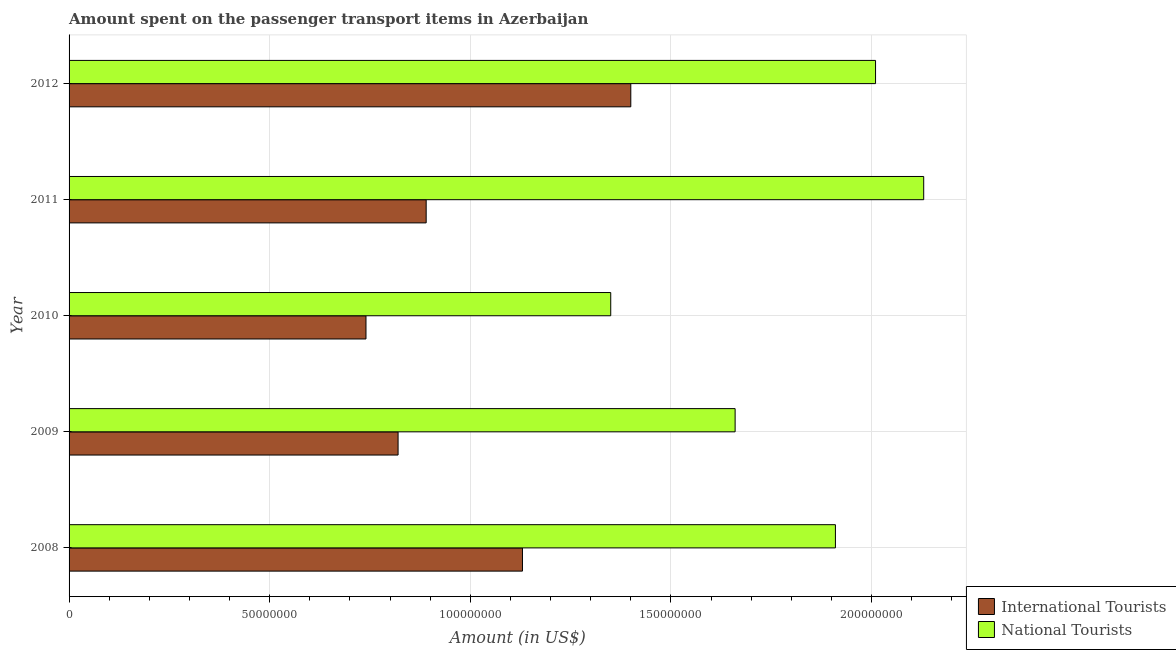How many different coloured bars are there?
Give a very brief answer. 2. How many bars are there on the 3rd tick from the top?
Offer a very short reply. 2. What is the label of the 5th group of bars from the top?
Your response must be concise. 2008. In how many cases, is the number of bars for a given year not equal to the number of legend labels?
Keep it short and to the point. 0. What is the amount spent on transport items of national tourists in 2012?
Your response must be concise. 2.01e+08. Across all years, what is the maximum amount spent on transport items of national tourists?
Your answer should be very brief. 2.13e+08. Across all years, what is the minimum amount spent on transport items of international tourists?
Offer a very short reply. 7.40e+07. In which year was the amount spent on transport items of national tourists maximum?
Your response must be concise. 2011. In which year was the amount spent on transport items of international tourists minimum?
Provide a short and direct response. 2010. What is the total amount spent on transport items of national tourists in the graph?
Your response must be concise. 9.06e+08. What is the difference between the amount spent on transport items of international tourists in 2009 and that in 2011?
Offer a terse response. -7.00e+06. What is the difference between the amount spent on transport items of international tourists in 2012 and the amount spent on transport items of national tourists in 2009?
Offer a very short reply. -2.60e+07. What is the average amount spent on transport items of international tourists per year?
Provide a succinct answer. 9.96e+07. In the year 2012, what is the difference between the amount spent on transport items of national tourists and amount spent on transport items of international tourists?
Ensure brevity in your answer.  6.10e+07. In how many years, is the amount spent on transport items of national tourists greater than 70000000 US$?
Ensure brevity in your answer.  5. What is the ratio of the amount spent on transport items of national tourists in 2009 to that in 2012?
Ensure brevity in your answer.  0.83. Is the difference between the amount spent on transport items of international tourists in 2008 and 2012 greater than the difference between the amount spent on transport items of national tourists in 2008 and 2012?
Keep it short and to the point. No. What is the difference between the highest and the second highest amount spent on transport items of national tourists?
Your response must be concise. 1.20e+07. What is the difference between the highest and the lowest amount spent on transport items of international tourists?
Your answer should be compact. 6.60e+07. In how many years, is the amount spent on transport items of international tourists greater than the average amount spent on transport items of international tourists taken over all years?
Provide a succinct answer. 2. What does the 2nd bar from the top in 2012 represents?
Your answer should be very brief. International Tourists. What does the 1st bar from the bottom in 2012 represents?
Your response must be concise. International Tourists. How many bars are there?
Provide a succinct answer. 10. How many years are there in the graph?
Provide a succinct answer. 5. Are the values on the major ticks of X-axis written in scientific E-notation?
Ensure brevity in your answer.  No. Does the graph contain any zero values?
Provide a succinct answer. No. Does the graph contain grids?
Provide a succinct answer. Yes. How many legend labels are there?
Ensure brevity in your answer.  2. What is the title of the graph?
Offer a terse response. Amount spent on the passenger transport items in Azerbaijan. What is the label or title of the X-axis?
Offer a terse response. Amount (in US$). What is the Amount (in US$) in International Tourists in 2008?
Provide a succinct answer. 1.13e+08. What is the Amount (in US$) of National Tourists in 2008?
Ensure brevity in your answer.  1.91e+08. What is the Amount (in US$) in International Tourists in 2009?
Provide a short and direct response. 8.20e+07. What is the Amount (in US$) of National Tourists in 2009?
Your response must be concise. 1.66e+08. What is the Amount (in US$) in International Tourists in 2010?
Offer a very short reply. 7.40e+07. What is the Amount (in US$) in National Tourists in 2010?
Make the answer very short. 1.35e+08. What is the Amount (in US$) of International Tourists in 2011?
Provide a short and direct response. 8.90e+07. What is the Amount (in US$) of National Tourists in 2011?
Your response must be concise. 2.13e+08. What is the Amount (in US$) of International Tourists in 2012?
Your answer should be compact. 1.40e+08. What is the Amount (in US$) of National Tourists in 2012?
Offer a very short reply. 2.01e+08. Across all years, what is the maximum Amount (in US$) of International Tourists?
Ensure brevity in your answer.  1.40e+08. Across all years, what is the maximum Amount (in US$) of National Tourists?
Your response must be concise. 2.13e+08. Across all years, what is the minimum Amount (in US$) in International Tourists?
Provide a succinct answer. 7.40e+07. Across all years, what is the minimum Amount (in US$) in National Tourists?
Your answer should be very brief. 1.35e+08. What is the total Amount (in US$) of International Tourists in the graph?
Your answer should be compact. 4.98e+08. What is the total Amount (in US$) in National Tourists in the graph?
Give a very brief answer. 9.06e+08. What is the difference between the Amount (in US$) of International Tourists in 2008 and that in 2009?
Offer a very short reply. 3.10e+07. What is the difference between the Amount (in US$) of National Tourists in 2008 and that in 2009?
Offer a terse response. 2.50e+07. What is the difference between the Amount (in US$) of International Tourists in 2008 and that in 2010?
Keep it short and to the point. 3.90e+07. What is the difference between the Amount (in US$) of National Tourists in 2008 and that in 2010?
Provide a short and direct response. 5.60e+07. What is the difference between the Amount (in US$) of International Tourists in 2008 and that in 2011?
Your answer should be very brief. 2.40e+07. What is the difference between the Amount (in US$) of National Tourists in 2008 and that in 2011?
Your response must be concise. -2.20e+07. What is the difference between the Amount (in US$) in International Tourists in 2008 and that in 2012?
Make the answer very short. -2.70e+07. What is the difference between the Amount (in US$) in National Tourists in 2008 and that in 2012?
Ensure brevity in your answer.  -1.00e+07. What is the difference between the Amount (in US$) of National Tourists in 2009 and that in 2010?
Offer a very short reply. 3.10e+07. What is the difference between the Amount (in US$) of International Tourists in 2009 and that in 2011?
Offer a terse response. -7.00e+06. What is the difference between the Amount (in US$) of National Tourists in 2009 and that in 2011?
Provide a short and direct response. -4.70e+07. What is the difference between the Amount (in US$) of International Tourists in 2009 and that in 2012?
Keep it short and to the point. -5.80e+07. What is the difference between the Amount (in US$) of National Tourists in 2009 and that in 2012?
Make the answer very short. -3.50e+07. What is the difference between the Amount (in US$) of International Tourists in 2010 and that in 2011?
Make the answer very short. -1.50e+07. What is the difference between the Amount (in US$) of National Tourists in 2010 and that in 2011?
Provide a succinct answer. -7.80e+07. What is the difference between the Amount (in US$) in International Tourists in 2010 and that in 2012?
Your response must be concise. -6.60e+07. What is the difference between the Amount (in US$) in National Tourists in 2010 and that in 2012?
Keep it short and to the point. -6.60e+07. What is the difference between the Amount (in US$) in International Tourists in 2011 and that in 2012?
Your answer should be very brief. -5.10e+07. What is the difference between the Amount (in US$) in International Tourists in 2008 and the Amount (in US$) in National Tourists in 2009?
Give a very brief answer. -5.30e+07. What is the difference between the Amount (in US$) of International Tourists in 2008 and the Amount (in US$) of National Tourists in 2010?
Your response must be concise. -2.20e+07. What is the difference between the Amount (in US$) of International Tourists in 2008 and the Amount (in US$) of National Tourists in 2011?
Keep it short and to the point. -1.00e+08. What is the difference between the Amount (in US$) in International Tourists in 2008 and the Amount (in US$) in National Tourists in 2012?
Provide a succinct answer. -8.80e+07. What is the difference between the Amount (in US$) in International Tourists in 2009 and the Amount (in US$) in National Tourists in 2010?
Your answer should be very brief. -5.30e+07. What is the difference between the Amount (in US$) in International Tourists in 2009 and the Amount (in US$) in National Tourists in 2011?
Ensure brevity in your answer.  -1.31e+08. What is the difference between the Amount (in US$) in International Tourists in 2009 and the Amount (in US$) in National Tourists in 2012?
Your response must be concise. -1.19e+08. What is the difference between the Amount (in US$) of International Tourists in 2010 and the Amount (in US$) of National Tourists in 2011?
Your answer should be compact. -1.39e+08. What is the difference between the Amount (in US$) in International Tourists in 2010 and the Amount (in US$) in National Tourists in 2012?
Offer a terse response. -1.27e+08. What is the difference between the Amount (in US$) in International Tourists in 2011 and the Amount (in US$) in National Tourists in 2012?
Keep it short and to the point. -1.12e+08. What is the average Amount (in US$) of International Tourists per year?
Provide a short and direct response. 9.96e+07. What is the average Amount (in US$) in National Tourists per year?
Your response must be concise. 1.81e+08. In the year 2008, what is the difference between the Amount (in US$) of International Tourists and Amount (in US$) of National Tourists?
Make the answer very short. -7.80e+07. In the year 2009, what is the difference between the Amount (in US$) of International Tourists and Amount (in US$) of National Tourists?
Your answer should be compact. -8.40e+07. In the year 2010, what is the difference between the Amount (in US$) in International Tourists and Amount (in US$) in National Tourists?
Your answer should be compact. -6.10e+07. In the year 2011, what is the difference between the Amount (in US$) of International Tourists and Amount (in US$) of National Tourists?
Keep it short and to the point. -1.24e+08. In the year 2012, what is the difference between the Amount (in US$) in International Tourists and Amount (in US$) in National Tourists?
Make the answer very short. -6.10e+07. What is the ratio of the Amount (in US$) of International Tourists in 2008 to that in 2009?
Your answer should be compact. 1.38. What is the ratio of the Amount (in US$) in National Tourists in 2008 to that in 2009?
Give a very brief answer. 1.15. What is the ratio of the Amount (in US$) in International Tourists in 2008 to that in 2010?
Provide a succinct answer. 1.53. What is the ratio of the Amount (in US$) in National Tourists in 2008 to that in 2010?
Offer a terse response. 1.41. What is the ratio of the Amount (in US$) in International Tourists in 2008 to that in 2011?
Provide a short and direct response. 1.27. What is the ratio of the Amount (in US$) of National Tourists in 2008 to that in 2011?
Ensure brevity in your answer.  0.9. What is the ratio of the Amount (in US$) of International Tourists in 2008 to that in 2012?
Keep it short and to the point. 0.81. What is the ratio of the Amount (in US$) of National Tourists in 2008 to that in 2012?
Ensure brevity in your answer.  0.95. What is the ratio of the Amount (in US$) in International Tourists in 2009 to that in 2010?
Your answer should be very brief. 1.11. What is the ratio of the Amount (in US$) in National Tourists in 2009 to that in 2010?
Your answer should be compact. 1.23. What is the ratio of the Amount (in US$) of International Tourists in 2009 to that in 2011?
Make the answer very short. 0.92. What is the ratio of the Amount (in US$) in National Tourists in 2009 to that in 2011?
Provide a short and direct response. 0.78. What is the ratio of the Amount (in US$) of International Tourists in 2009 to that in 2012?
Keep it short and to the point. 0.59. What is the ratio of the Amount (in US$) in National Tourists in 2009 to that in 2012?
Offer a very short reply. 0.83. What is the ratio of the Amount (in US$) in International Tourists in 2010 to that in 2011?
Ensure brevity in your answer.  0.83. What is the ratio of the Amount (in US$) in National Tourists in 2010 to that in 2011?
Keep it short and to the point. 0.63. What is the ratio of the Amount (in US$) of International Tourists in 2010 to that in 2012?
Provide a short and direct response. 0.53. What is the ratio of the Amount (in US$) in National Tourists in 2010 to that in 2012?
Make the answer very short. 0.67. What is the ratio of the Amount (in US$) of International Tourists in 2011 to that in 2012?
Make the answer very short. 0.64. What is the ratio of the Amount (in US$) in National Tourists in 2011 to that in 2012?
Your response must be concise. 1.06. What is the difference between the highest and the second highest Amount (in US$) of International Tourists?
Your answer should be very brief. 2.70e+07. What is the difference between the highest and the lowest Amount (in US$) in International Tourists?
Give a very brief answer. 6.60e+07. What is the difference between the highest and the lowest Amount (in US$) of National Tourists?
Keep it short and to the point. 7.80e+07. 